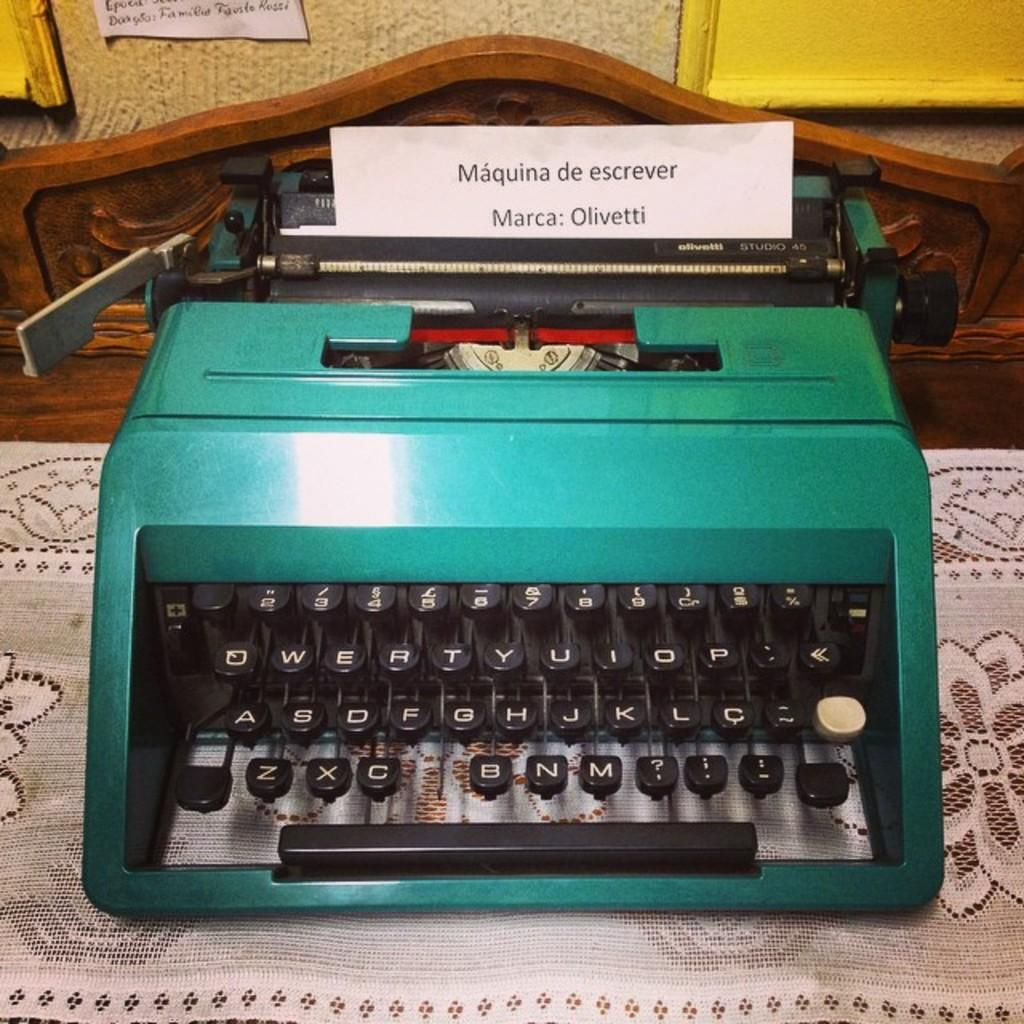<image>
Share a concise interpretation of the image provided. A piece of paper coming out of a green typewriter has the words "Maquina de escrever" at the top of the page. 